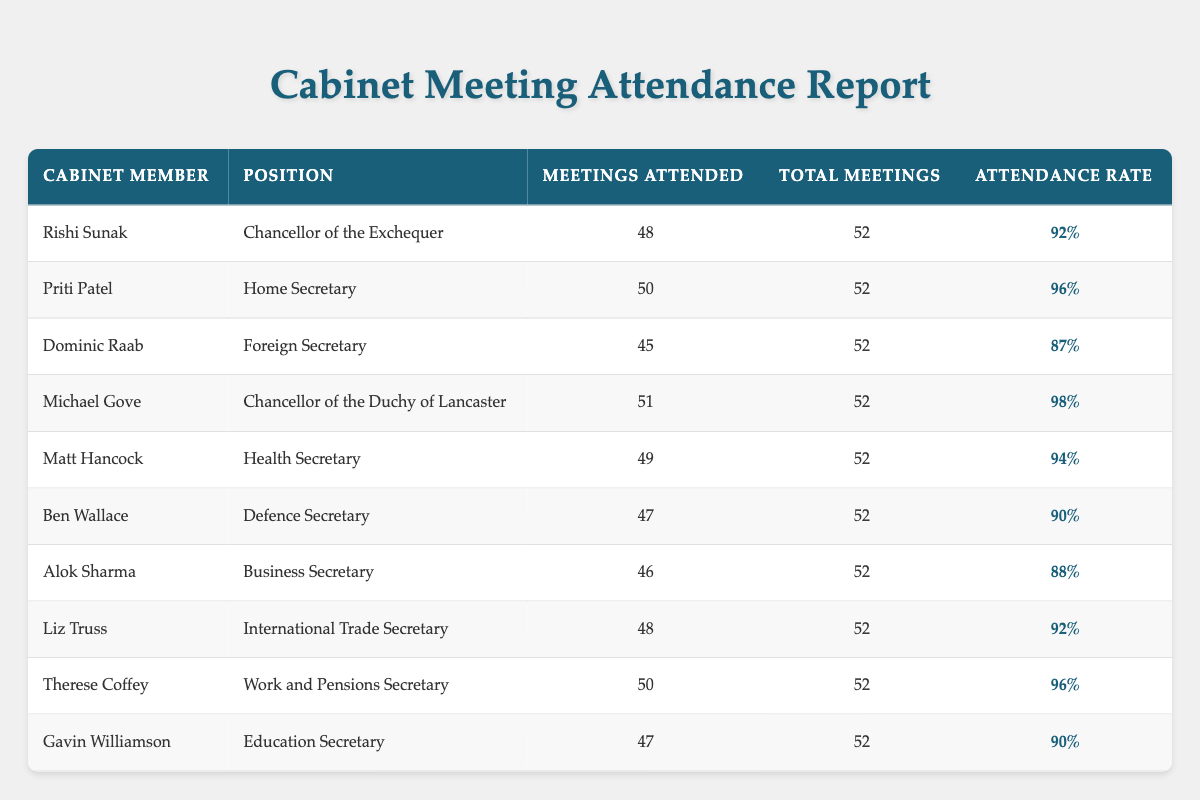What is the attendance rate for Michael Gove? Looking at the row corresponding to Michael Gove, his attendance rate is listed in the fifth column. It states “98%.”
Answer: 98% How many meetings did Priti Patel attend? By checking the data for Priti Patel in the table, we find that she attended 50 meetings, which is reflected in the third column of her row.
Answer: 50 Which cabinet member has the highest attendance rate? We can compare the attendance rates listed in the last column for each member. The maximum value found is “98%” for Michael Gove, thereby making him the cabinet member with the highest attendance rate.
Answer: Michael Gove What is the total number of meetings attended by all cabinet members? To find this total, we sum the number of meetings attended by each member: 48 + 50 + 45 + 51 + 49 + 47 + 46 + 48 + 50 + 47 = 462. Thus, the total number of attendance across all members is 462.
Answer: 462 Is the attendance rate for Matt Hancock higher than 90%? Checking Matt Hancock's attendance rate in the table, we see it is "94%." Since 94% is greater than 90%, the answer is yes.
Answer: Yes Who attended fewer meetings, Alok Sharma or Gavin Williamson? We compare the meetings attended by Alok Sharma (46) and Gavin Williamson (47). Since 46 is less than 47, Alok Sharma attended fewer meetings.
Answer: Alok Sharma What is the average attendance rate of all the cabinet members? To find the average attendance rate, we convert all rates to numbers, sum them: 92 + 96 + 87 + 98 + 94 + 90 + 88 + 92 + 96 + 90 = 917, and then divide by 10 (the number of members). The average attendance rate is 917 / 10 = 91.7%.
Answer: 91.7% Is there any cabinet member with an attendance rate below 90%? By reviewing the attendance rates in the last column, both Alok Sharma (88%) and Dominic Raab (87%) have rates below 90%, confirming that yes, there are members below this threshold.
Answer: Yes What is the difference in the number of meetings attended between the member with the most and the member with the least number of meetings? The maximum number of meetings attended is 51 (Michael Gove), and the minimum is 45 (Dominic Raab). The difference is 51 - 45 = 6.
Answer: 6 